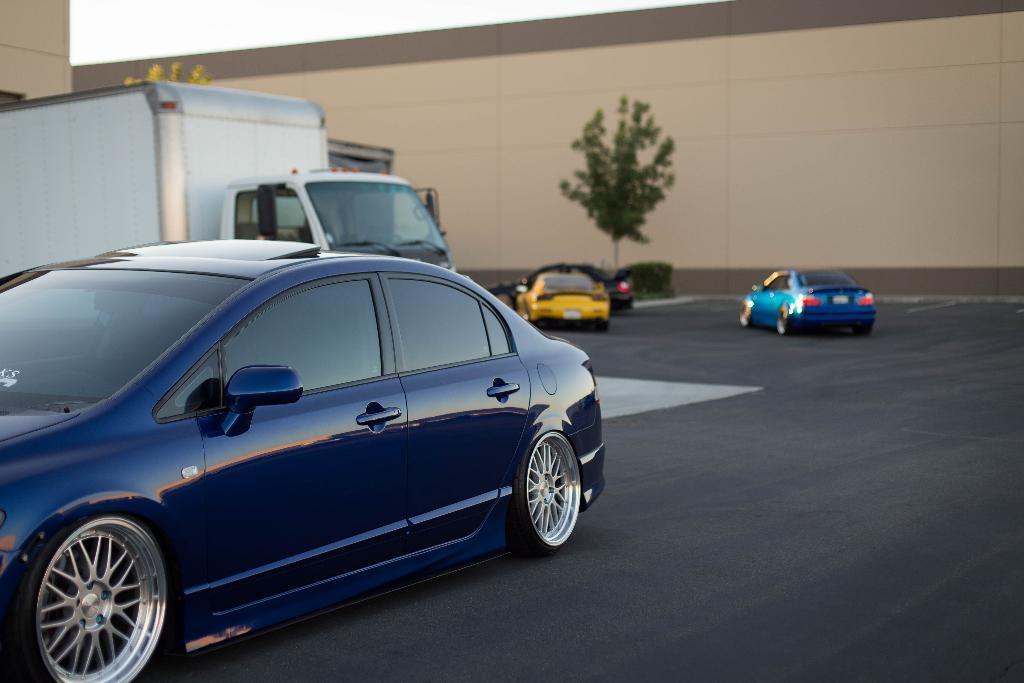In one or two sentences, can you explain what this image depicts? In this picture we can see cars and a truck, at the bottom there is road, in the background we can see a wall, there are trees in the middle, we can see the sky at the top of the picture. 